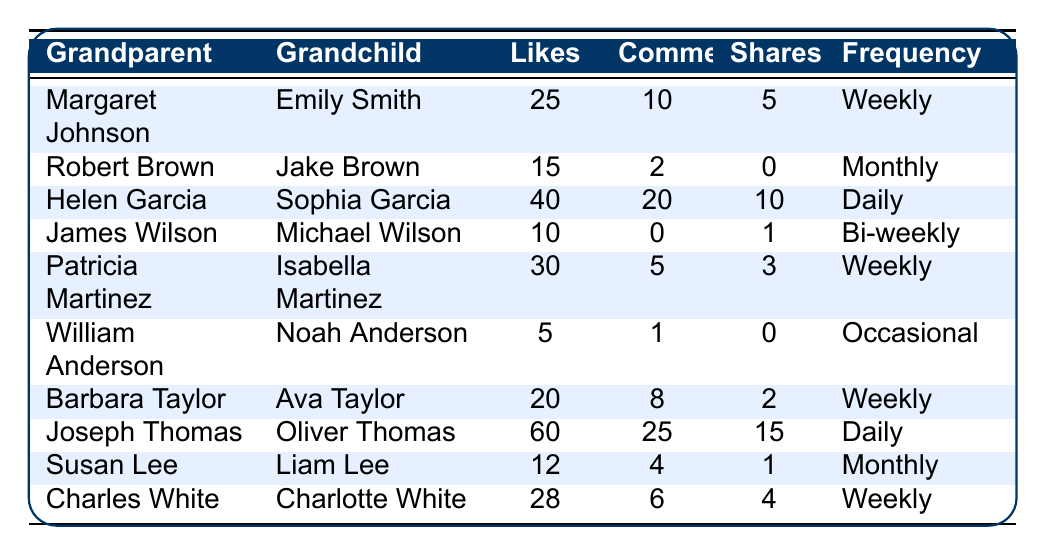What is the total number of likes from all grandparents? To find the total number of likes, sum the values of likes in the table: 25 + 15 + 40 + 10 + 30 + 5 + 20 + 60 + 12 + 28 =  10. The total number of likes is 245.
Answer: 245 How many grandparents interact with their grandchildren on a weekly basis? The table lists the interaction frequency for each grandparent. Counting those with "Weekly" frequency: Margaret Johnson, Patricia Martinez, Barbara Taylor, and Charles White gives us 4 grandparent entries.
Answer: 4 Which grandchild receives the highest number of likes, and how many do they receive? Looking through the likes, Joseph Thomas's grandchild, Oliver Thomas, has the highest likes at 60.
Answer: Oliver Thomas, 60 Is there a grandparent who has never shared any posts? Checking the shares column, both Robert Brown (0 shares) and William Anderson (0 shares) have not shared any posts. Therefore, the answer is yes.
Answer: Yes What is the average number of comments made by the grandparents? To find the average, sum the comments: 10 + 2 + 20 + 0 + 5 + 1 + 8 + 25 + 4 + 6 = 81. Then, divide by the number of entries (10): 81/10 = 8.1.
Answer: 8.1 How many interactions (likes, comments, shares) did Helen Garcia make in total? For Helen Garcia, sum her likes (40), comments (20), and shares (10): 40 + 20 + 10 = 70 total interactions.
Answer: 70 Which grandparent has the least number of interactions overall? Calculate total interactions for each grandparent and find the least: William Anderson has likes (5) + comments (1) + shares (0) = 6. He has the least interactions overall.
Answer: William Anderson How many more likes does Joseph Thomas have compared to Robert Brown? Joseph Thomas has 60 likes and Robert Brown has 15 likes. The difference is 60 - 15 = 45.
Answer: 45 Are there any grandparents with a frequency of "Occasional"? Yes, looking through the table, William Anderson is noted for having an interaction frequency of "Occasional."
Answer: Yes What is the total number of shares for grandparents who interact daily? Identify daily interactions: Helen Garcia (10 shares) and Joseph Thomas (15 shares). Total is 10 + 15 = 25 shares.
Answer: 25 